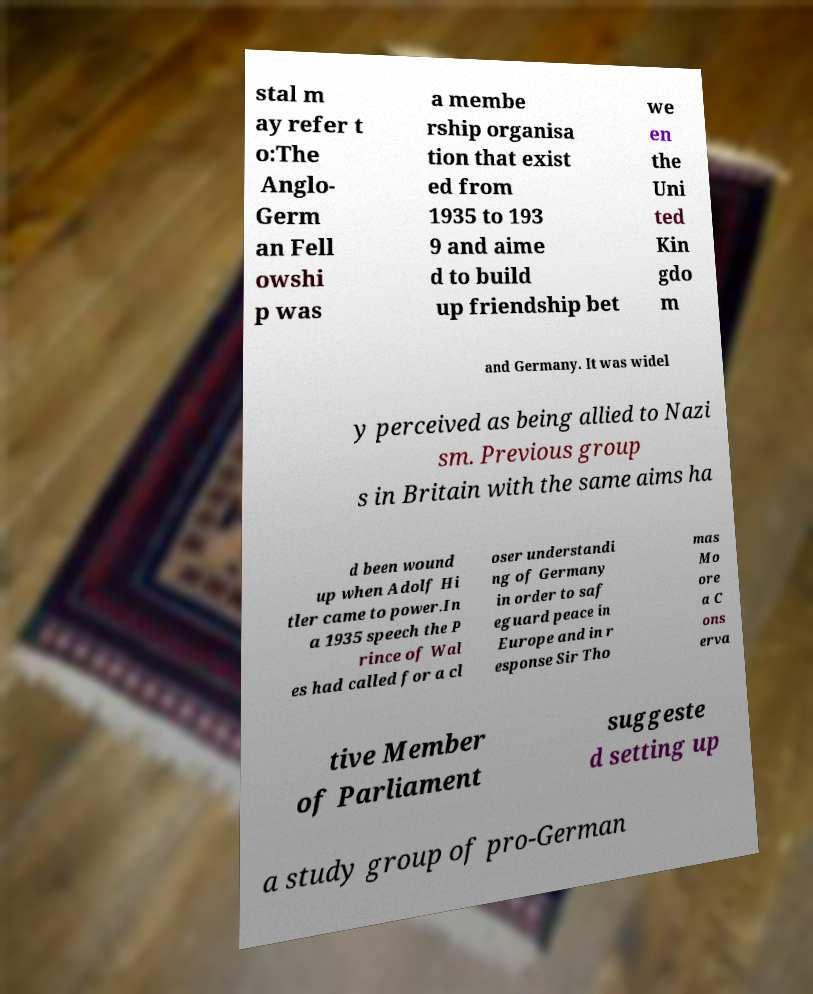For documentation purposes, I need the text within this image transcribed. Could you provide that? stal m ay refer t o:The Anglo- Germ an Fell owshi p was a membe rship organisa tion that exist ed from 1935 to 193 9 and aime d to build up friendship bet we en the Uni ted Kin gdo m and Germany. It was widel y perceived as being allied to Nazi sm. Previous group s in Britain with the same aims ha d been wound up when Adolf Hi tler came to power.In a 1935 speech the P rince of Wal es had called for a cl oser understandi ng of Germany in order to saf eguard peace in Europe and in r esponse Sir Tho mas Mo ore a C ons erva tive Member of Parliament suggeste d setting up a study group of pro-German 